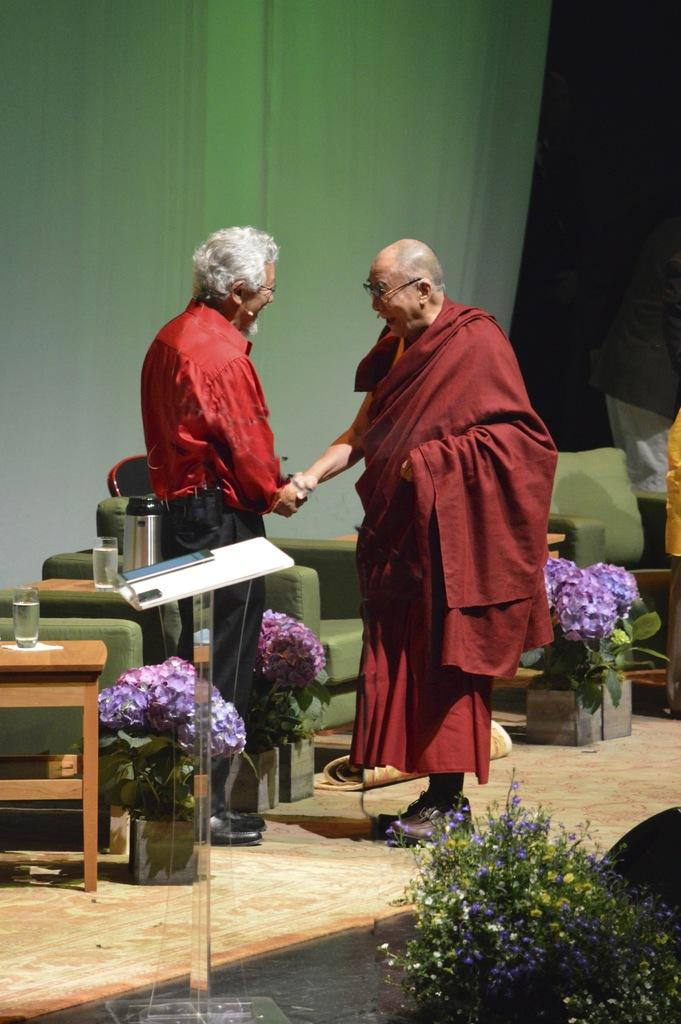How many people are present in the image? There are two people in the image. What are the people doing in the image? The facts do not specify what the people are doing, but they are standing on a floor. What can be seen in the background of the image? There is a table, chairs, and a wall in the background of the image. What color is the blood on the shirt of the person in the image? There is no blood or shirt mentioned in the image, so this question cannot be answered. 